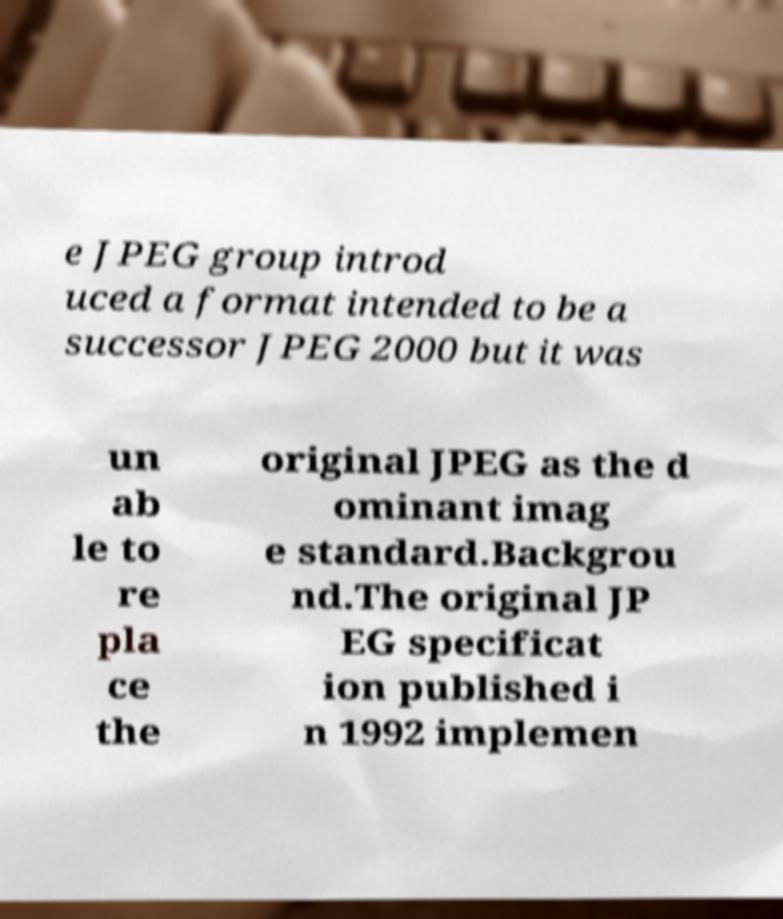For documentation purposes, I need the text within this image transcribed. Could you provide that? e JPEG group introd uced a format intended to be a successor JPEG 2000 but it was un ab le to re pla ce the original JPEG as the d ominant imag e standard.Backgrou nd.The original JP EG specificat ion published i n 1992 implemen 